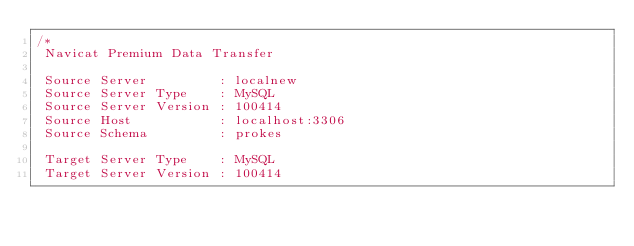<code> <loc_0><loc_0><loc_500><loc_500><_SQL_>/*
 Navicat Premium Data Transfer

 Source Server         : localnew
 Source Server Type    : MySQL
 Source Server Version : 100414
 Source Host           : localhost:3306
 Source Schema         : prokes

 Target Server Type    : MySQL
 Target Server Version : 100414</code> 